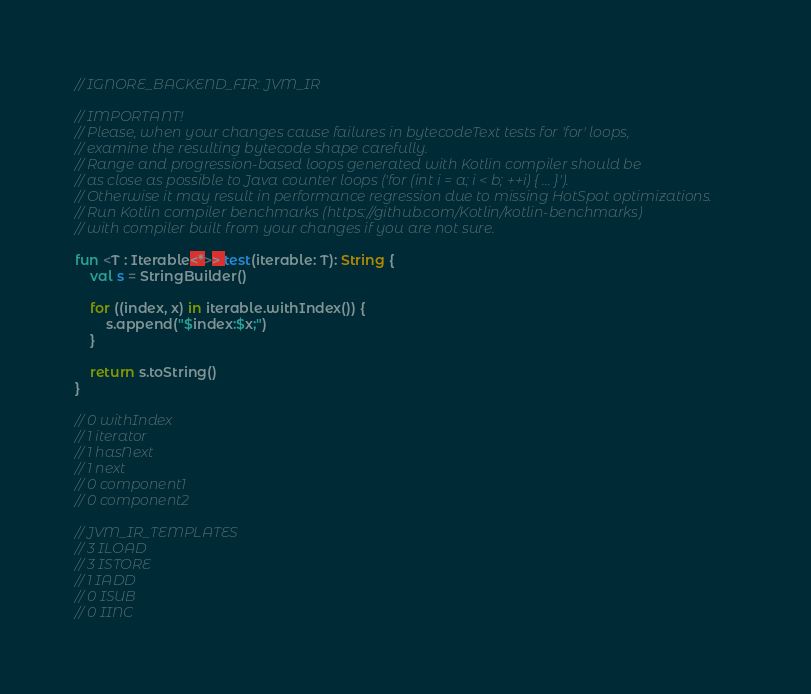Convert code to text. <code><loc_0><loc_0><loc_500><loc_500><_Kotlin_>// IGNORE_BACKEND_FIR: JVM_IR

// IMPORTANT!
// Please, when your changes cause failures in bytecodeText tests for 'for' loops,
// examine the resulting bytecode shape carefully.
// Range and progression-based loops generated with Kotlin compiler should be
// as close as possible to Java counter loops ('for (int i = a; i < b; ++i) { ... }').
// Otherwise it may result in performance regression due to missing HotSpot optimizations.
// Run Kotlin compiler benchmarks (https://github.com/Kotlin/kotlin-benchmarks)
// with compiler built from your changes if you are not sure.

fun <T : Iterable<*>> test(iterable: T): String {
    val s = StringBuilder()

    for ((index, x) in iterable.withIndex()) {
        s.append("$index:$x;")
    }

    return s.toString()
}

// 0 withIndex
// 1 iterator
// 1 hasNext
// 1 next
// 0 component1
// 0 component2

// JVM_IR_TEMPLATES
// 3 ILOAD
// 3 ISTORE
// 1 IADD
// 0 ISUB
// 0 IINC
</code> 